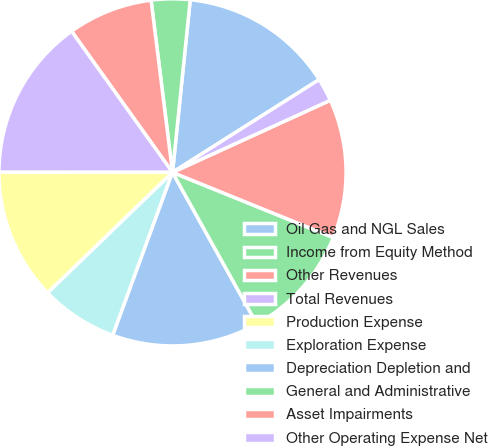Convert chart. <chart><loc_0><loc_0><loc_500><loc_500><pie_chart><fcel>Oil Gas and NGL Sales<fcel>Income from Equity Method<fcel>Other Revenues<fcel>Total Revenues<fcel>Production Expense<fcel>Exploration Expense<fcel>Depreciation Depletion and<fcel>General and Administrative<fcel>Asset Impairments<fcel>Other Operating Expense Net<nl><fcel>14.39%<fcel>3.6%<fcel>7.91%<fcel>15.11%<fcel>12.23%<fcel>7.19%<fcel>13.67%<fcel>10.79%<fcel>12.95%<fcel>2.16%<nl></chart> 